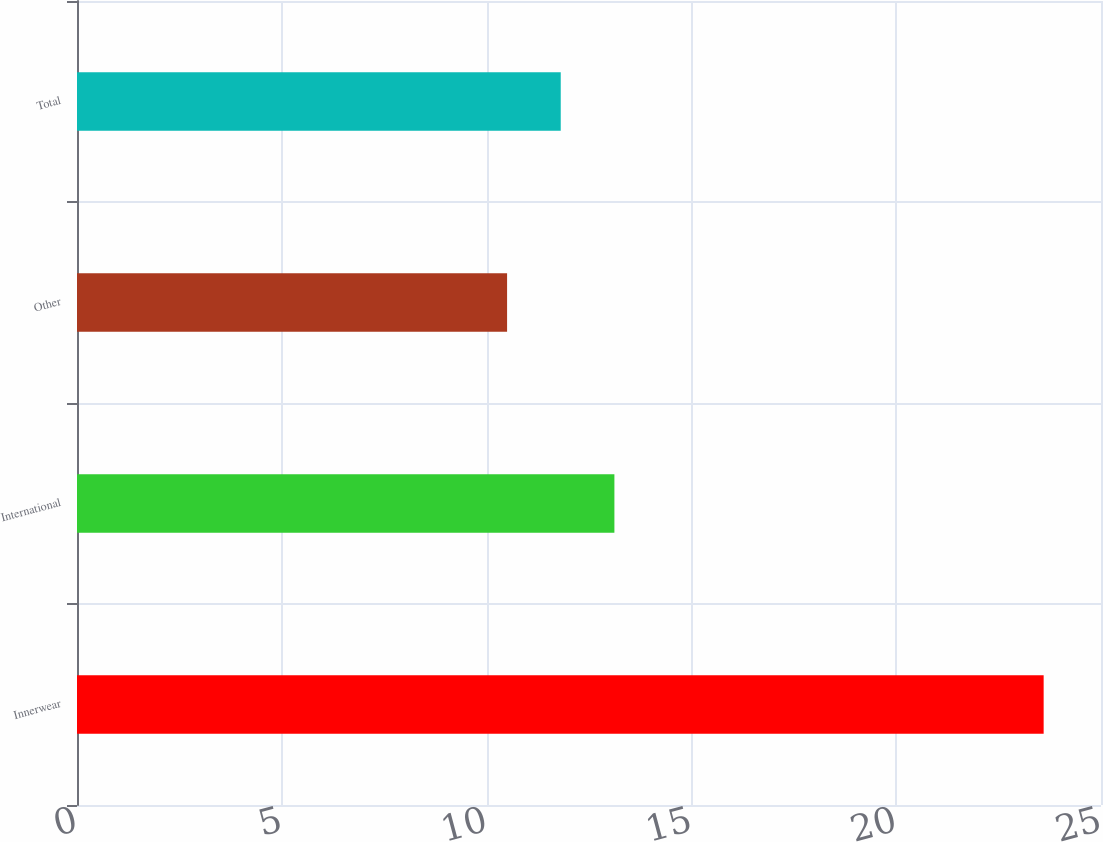<chart> <loc_0><loc_0><loc_500><loc_500><bar_chart><fcel>Innerwear<fcel>International<fcel>Other<fcel>Total<nl><fcel>23.6<fcel>13.12<fcel>10.5<fcel>11.81<nl></chart> 